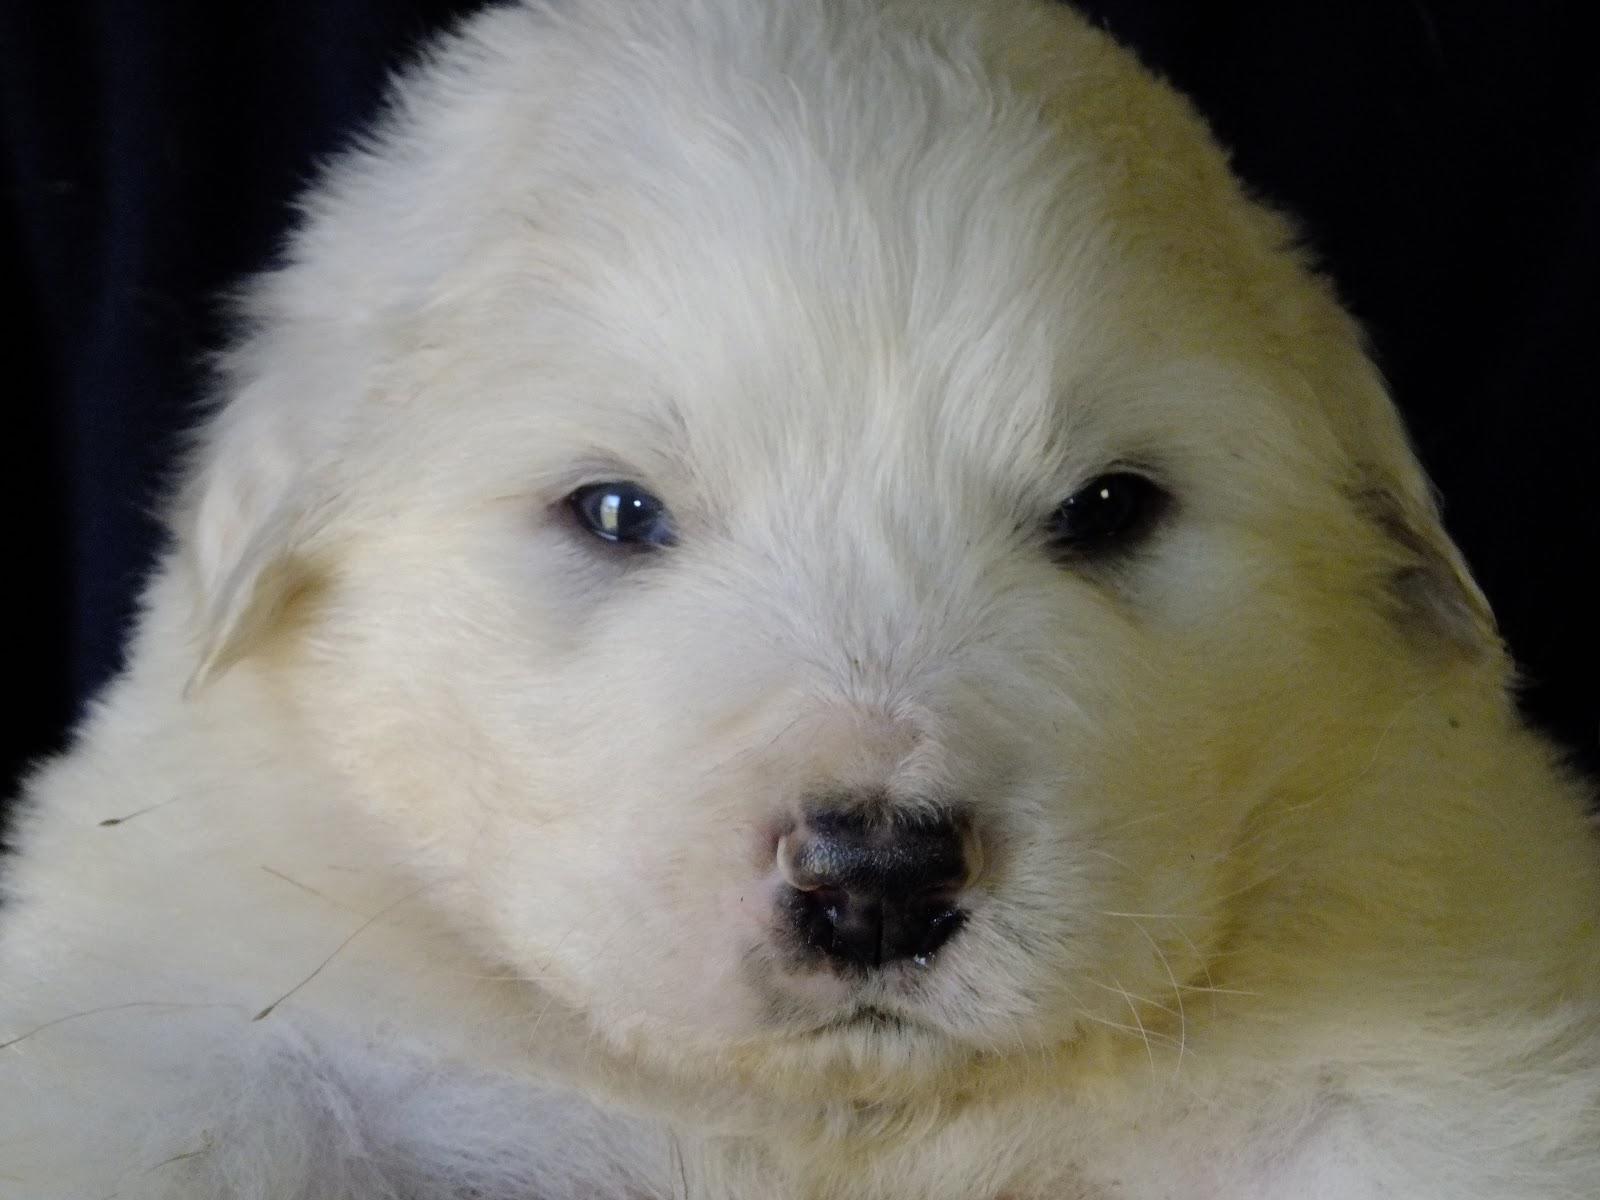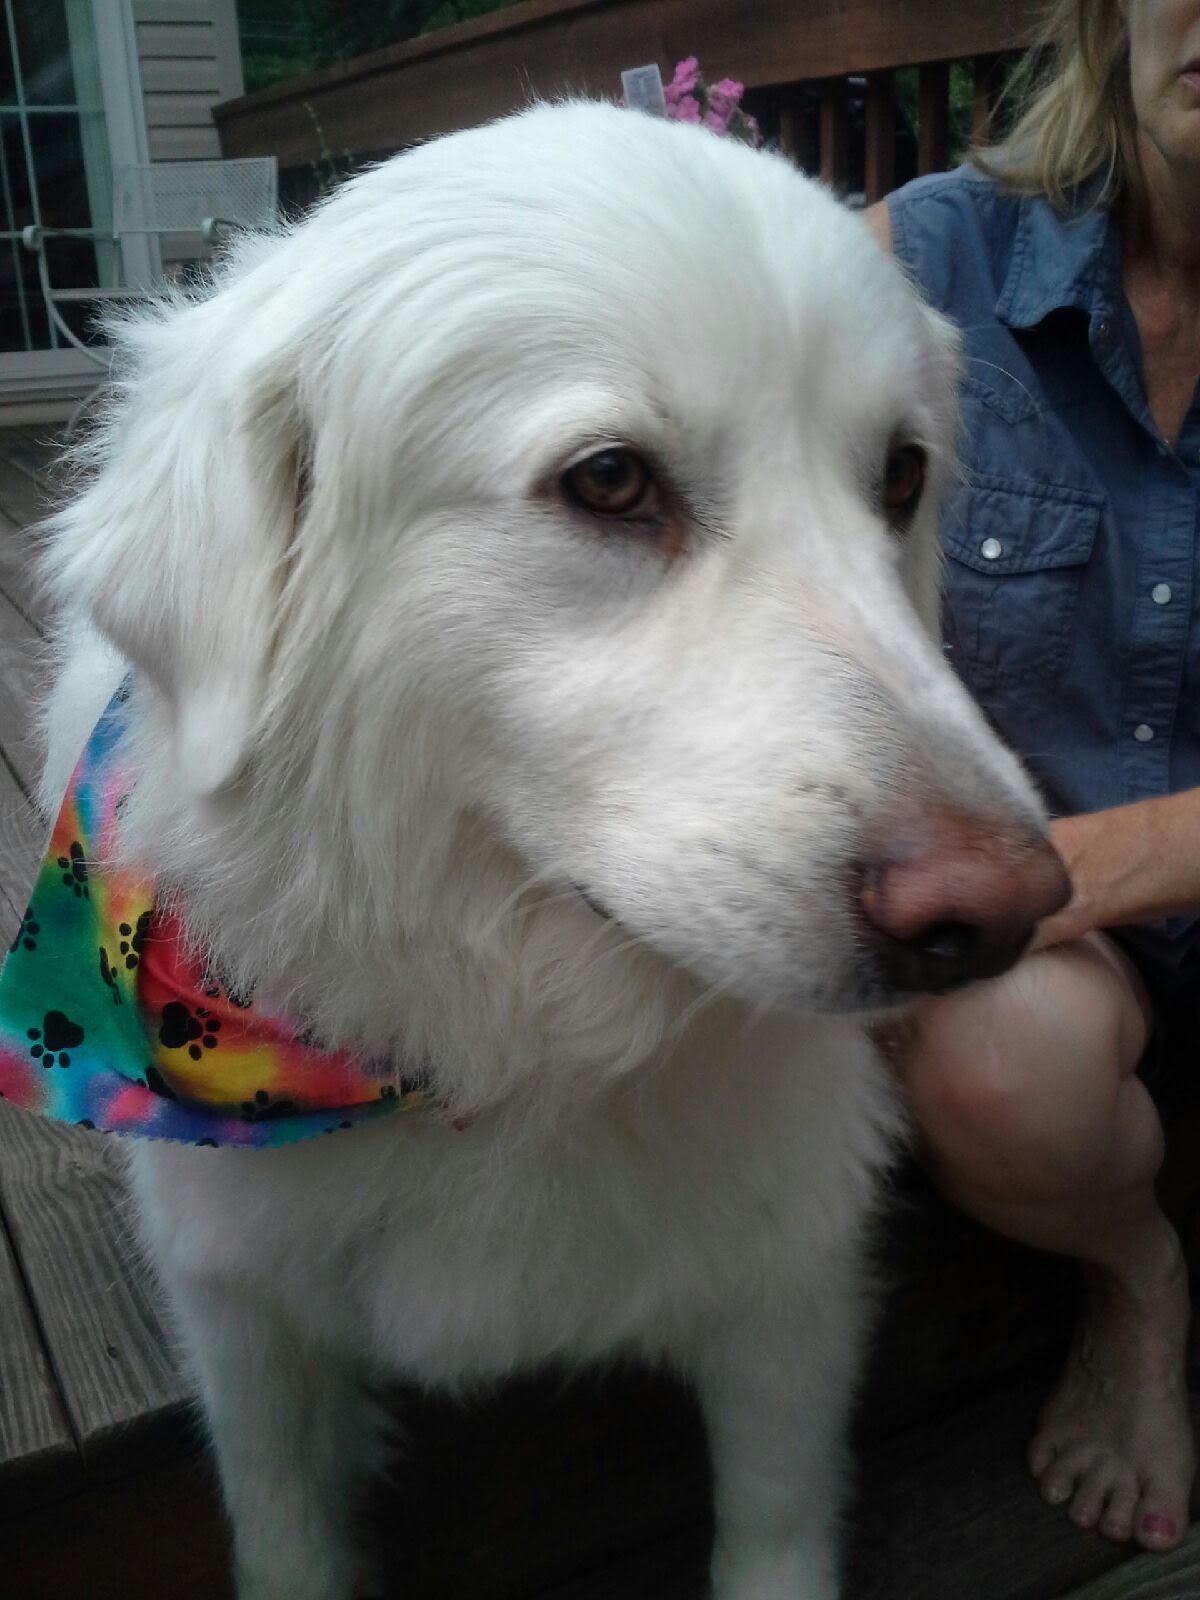The first image is the image on the left, the second image is the image on the right. Evaluate the accuracy of this statement regarding the images: "The left photo is of a puppy.". Is it true? Answer yes or no. Yes. 